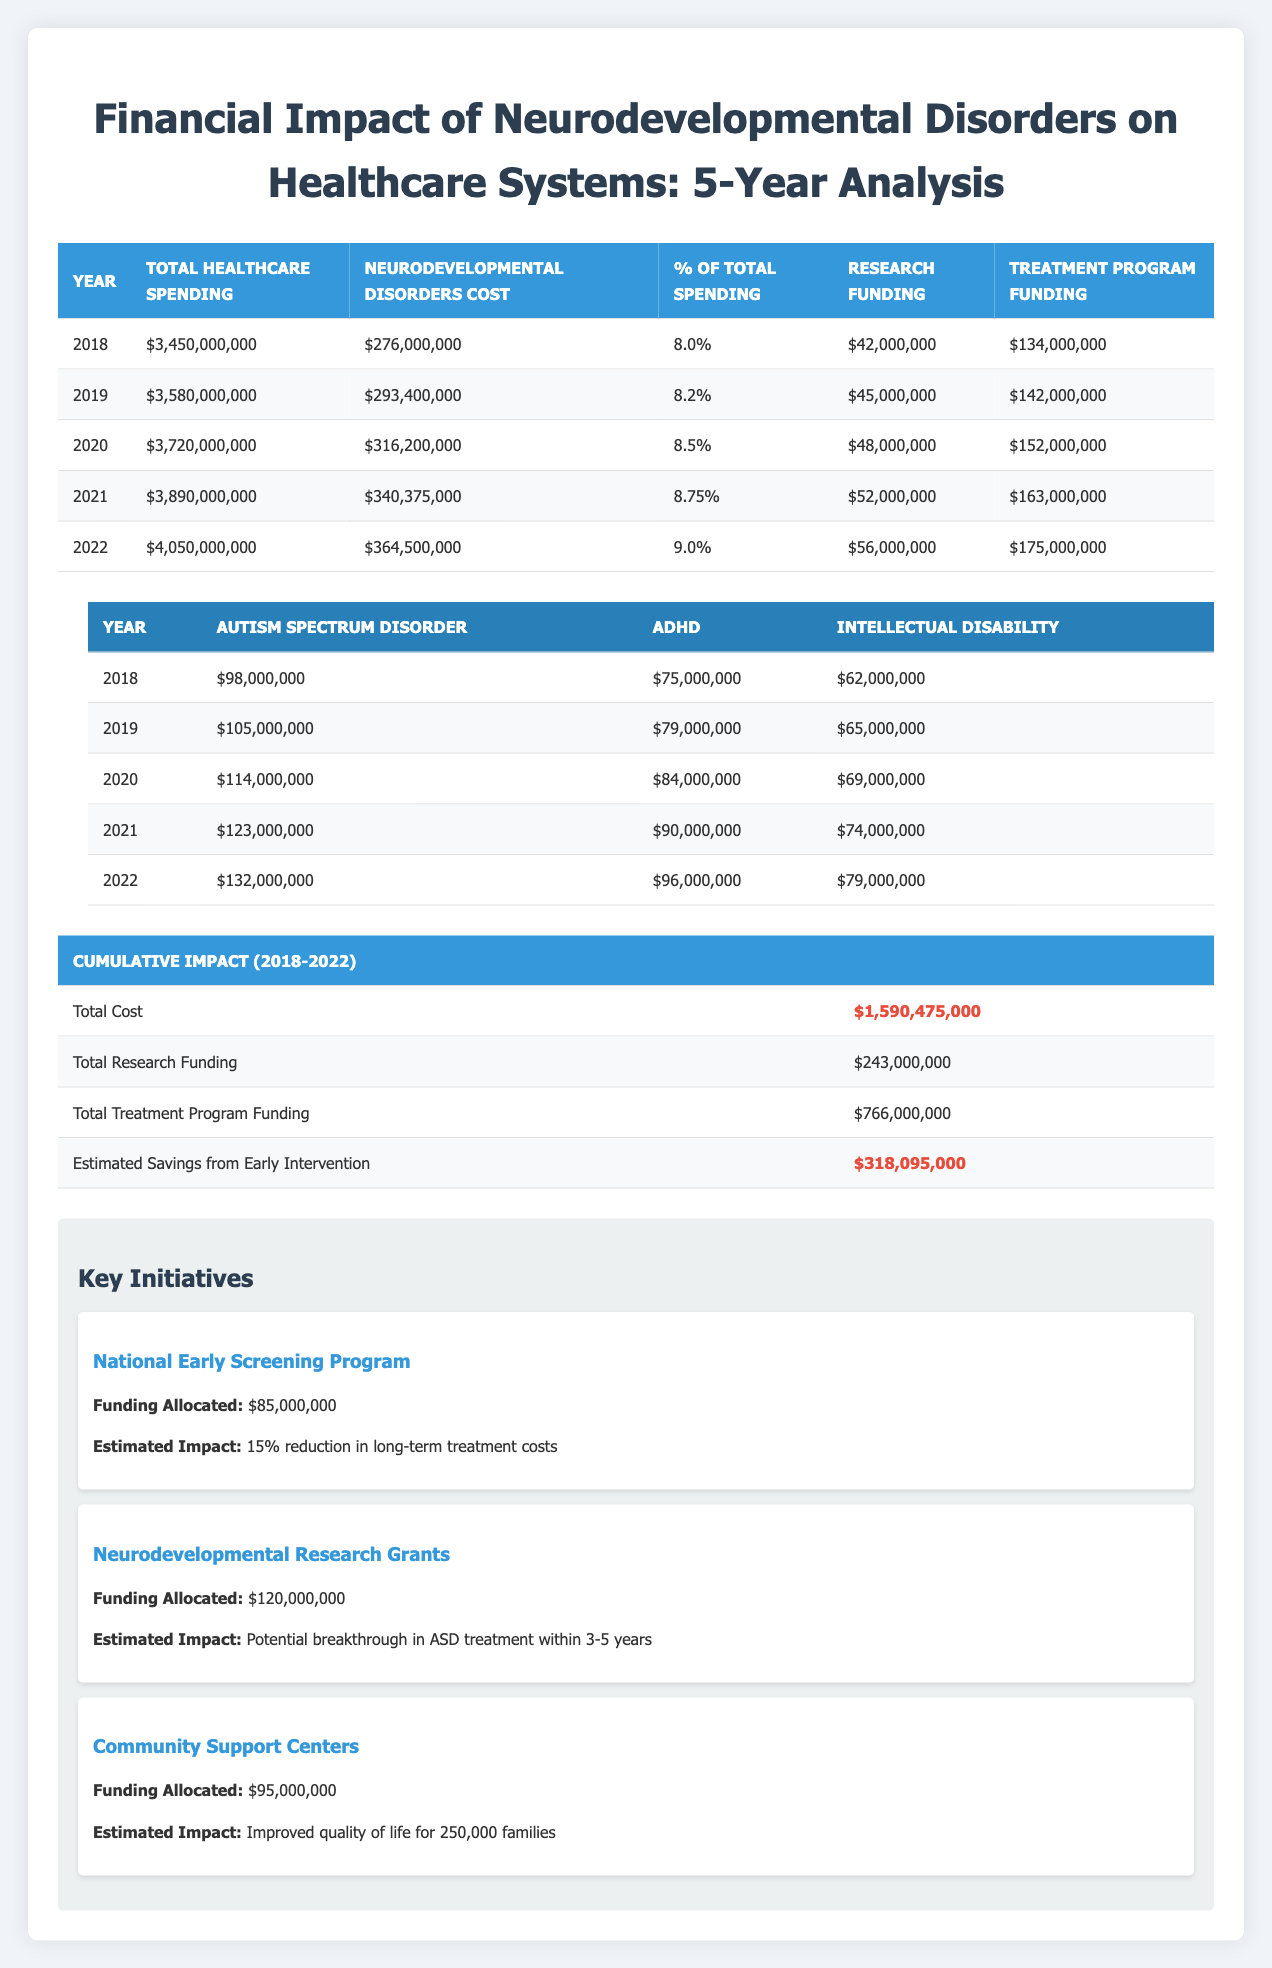What was the total healthcare spending in 2020? Referring to the table for the year 2020, the total healthcare spending is listed as $3,720,000,000.
Answer: $3,720,000,000 What percentage of total spending did neurodevelopmental disorders represent in 2021? Looking at the table for the year 2021, the percentage of total spending attributed to neurodevelopmental disorders is 8.75%.
Answer: 8.75% What was the increase in costs for neurodevelopmental disorders from 2018 to 2022? To find this, subtract the neurodevelopmental disorders cost in 2018 ($276,000,000) from the cost in 2022 ($364,500,000). The difference is $364,500,000 - $276,000,000 = $88,500,000.
Answer: $88,500,000 Did the research funding increase every year from 2018 to 2022? By comparing the research funding values for each year: $42,000,000 in 2018, $45,000,000 in 2019, $48,000,000 in 2020, $52,000,000 in 2021, and $56,000,000 in 2022, we can see that it consistently increased.
Answer: Yes What is the cumulative total cost of neurodevelopmental disorders over the five years? The cumulative total cost is provided in the table as $1,590,475,000. This value represents the sum of costs for neurodevelopmental disorders from 2018 to 2022.
Answer: $1,590,475,000 How much funding was allocated to the Neurodevelopmental Research Grants? The table indicates that the funding allocated to the Neurodevelopmental Research Grants is $120,000,000.
Answer: $120,000,000 What was the average treatment program funding from 2018 to 2022? To calculate the average treatment program funding, sum the annual funding amounts: $134,000,000 + $142,000,000 + $152,000,000 + $163,000,000 + $175,000,000 = $766,000,000, then divide by 5 (the number of years): $766,000,000 / 5 = $153,200,000.
Answer: $153,200,000 By how much did the cost for Autism Spectrum Disorder grow from 2018 to 2022? The cost for Autism Spectrum Disorder in 2018 was $98,000,000 and in 2022 it was $132,000,000. The increase is calculated as $132,000,000 - $98,000,000 = $34,000,000.
Answer: $34,000,000 Was the estimated savings from early intervention higher than the total research funding? The estimated savings from early intervention is $318,095,000, while total research funding is $243,000,000. Since $318,095,000 is greater than $243,000,000, the answer is yes.
Answer: Yes 